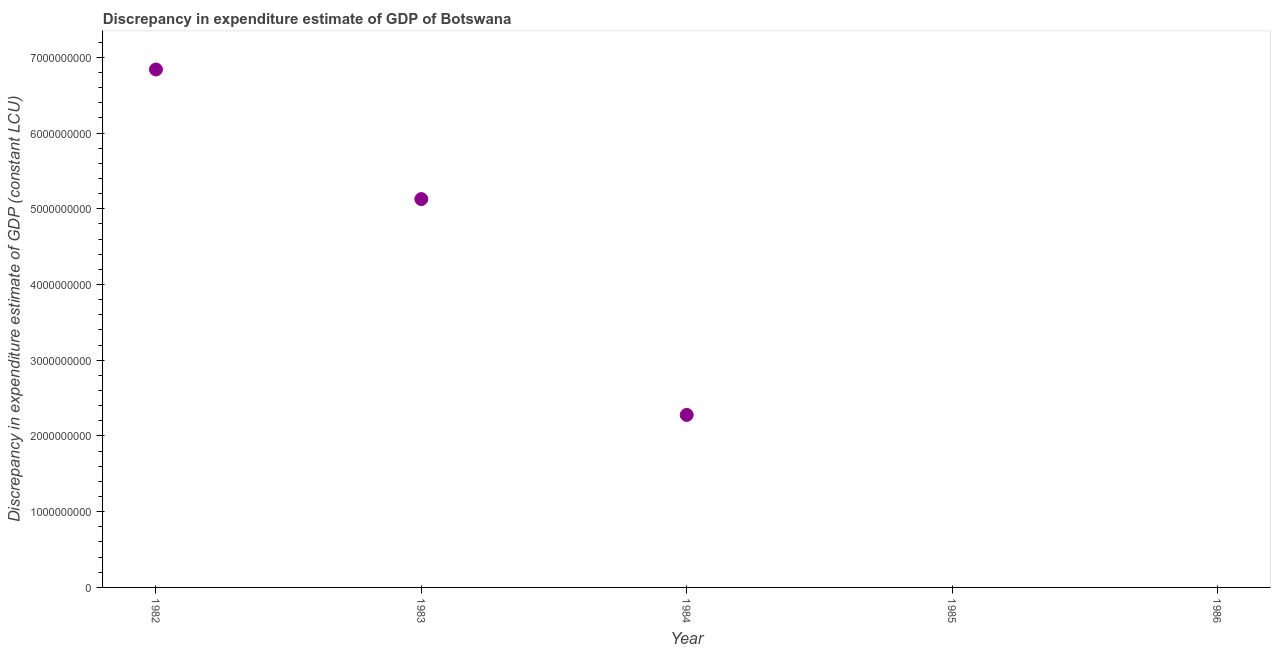What is the discrepancy in expenditure estimate of gdp in 1983?
Ensure brevity in your answer.  5.13e+09. Across all years, what is the maximum discrepancy in expenditure estimate of gdp?
Make the answer very short. 6.84e+09. Across all years, what is the minimum discrepancy in expenditure estimate of gdp?
Your response must be concise. 0. In which year was the discrepancy in expenditure estimate of gdp maximum?
Your answer should be compact. 1982. What is the sum of the discrepancy in expenditure estimate of gdp?
Your response must be concise. 1.42e+1. What is the difference between the discrepancy in expenditure estimate of gdp in 1982 and 1983?
Give a very brief answer. 1.71e+09. What is the average discrepancy in expenditure estimate of gdp per year?
Offer a very short reply. 2.85e+09. What is the median discrepancy in expenditure estimate of gdp?
Offer a terse response. 2.28e+09. What is the ratio of the discrepancy in expenditure estimate of gdp in 1982 to that in 1983?
Give a very brief answer. 1.33. Is the discrepancy in expenditure estimate of gdp in 1982 less than that in 1984?
Ensure brevity in your answer.  No. Is the difference between the discrepancy in expenditure estimate of gdp in 1983 and 1984 greater than the difference between any two years?
Make the answer very short. No. What is the difference between the highest and the second highest discrepancy in expenditure estimate of gdp?
Provide a short and direct response. 1.71e+09. What is the difference between the highest and the lowest discrepancy in expenditure estimate of gdp?
Make the answer very short. 6.84e+09. In how many years, is the discrepancy in expenditure estimate of gdp greater than the average discrepancy in expenditure estimate of gdp taken over all years?
Your answer should be very brief. 2. Does the discrepancy in expenditure estimate of gdp monotonically increase over the years?
Your answer should be very brief. No. How many years are there in the graph?
Your answer should be very brief. 5. Does the graph contain any zero values?
Provide a short and direct response. Yes. Does the graph contain grids?
Make the answer very short. No. What is the title of the graph?
Your answer should be very brief. Discrepancy in expenditure estimate of GDP of Botswana. What is the label or title of the X-axis?
Make the answer very short. Year. What is the label or title of the Y-axis?
Give a very brief answer. Discrepancy in expenditure estimate of GDP (constant LCU). What is the Discrepancy in expenditure estimate of GDP (constant LCU) in 1982?
Keep it short and to the point. 6.84e+09. What is the Discrepancy in expenditure estimate of GDP (constant LCU) in 1983?
Keep it short and to the point. 5.13e+09. What is the Discrepancy in expenditure estimate of GDP (constant LCU) in 1984?
Your answer should be very brief. 2.28e+09. What is the Discrepancy in expenditure estimate of GDP (constant LCU) in 1985?
Ensure brevity in your answer.  0. What is the difference between the Discrepancy in expenditure estimate of GDP (constant LCU) in 1982 and 1983?
Make the answer very short. 1.71e+09. What is the difference between the Discrepancy in expenditure estimate of GDP (constant LCU) in 1982 and 1984?
Your response must be concise. 4.56e+09. What is the difference between the Discrepancy in expenditure estimate of GDP (constant LCU) in 1983 and 1984?
Your answer should be compact. 2.85e+09. What is the ratio of the Discrepancy in expenditure estimate of GDP (constant LCU) in 1982 to that in 1983?
Your answer should be compact. 1.33. What is the ratio of the Discrepancy in expenditure estimate of GDP (constant LCU) in 1982 to that in 1984?
Keep it short and to the point. 3. What is the ratio of the Discrepancy in expenditure estimate of GDP (constant LCU) in 1983 to that in 1984?
Provide a short and direct response. 2.25. 